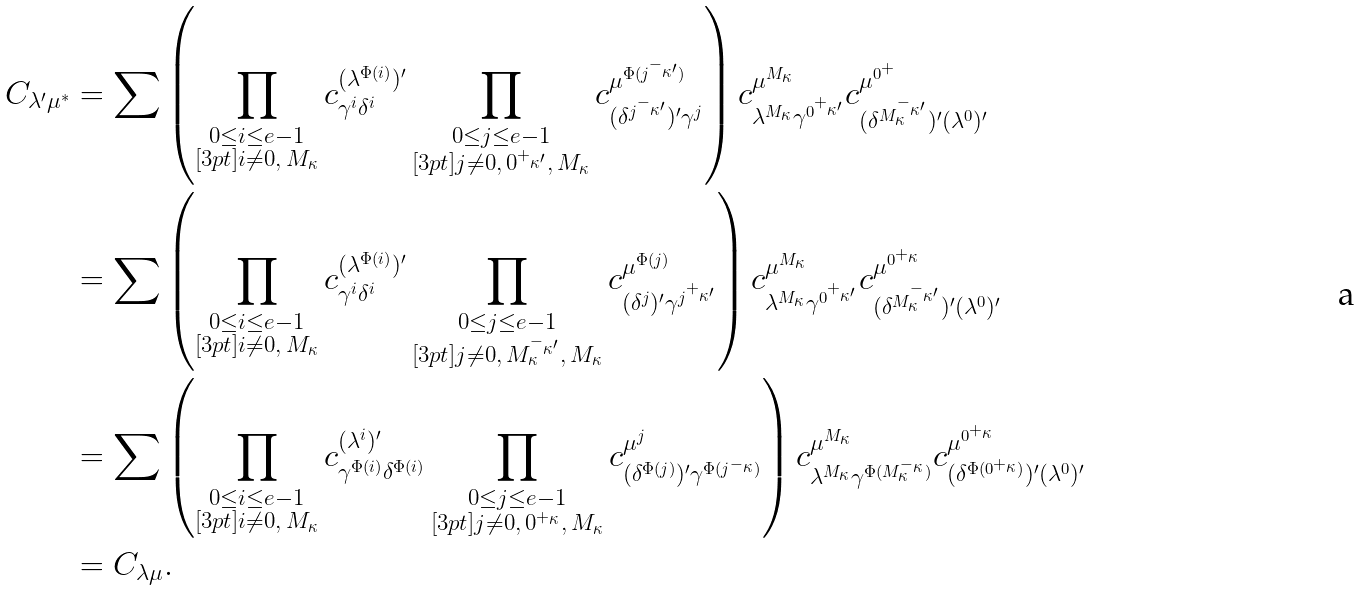<formula> <loc_0><loc_0><loc_500><loc_500>C _ { \lambda ^ { \prime } \mu ^ { * } } & = \sum \left ( \prod _ { \substack { 0 \leq i \leq e - 1 \\ [ 3 p t ] i \ne 0 , \, M _ { \kappa } } } c ^ { ( \lambda ^ { \Phi ( i ) } ) ^ { \prime } } _ { \gamma ^ { i } \delta ^ { i } } \prod _ { \substack { 0 \leq j \leq e - 1 \\ [ 3 p t ] j \ne 0 , \, 0 ^ { + _ { \kappa ^ { \prime } } } , \, M _ { \kappa } } } c ^ { \mu ^ { \Phi ( j ^ { - _ { \kappa ^ { \prime } } } ) } } _ { ( \delta ^ { j ^ { - _ { \kappa ^ { \prime } } } } ) ^ { \prime } \gamma ^ { j } } \right ) c ^ { \mu ^ { M _ { \kappa } } } _ { \lambda ^ { M _ { \kappa } } \gamma ^ { 0 ^ { + _ { \kappa ^ { \prime } } } } } c ^ { \mu ^ { 0 ^ { + } } } _ { ( \delta ^ { M _ { \kappa } ^ { - _ { \kappa ^ { \prime } } } } ) ^ { \prime } ( \lambda ^ { 0 } ) ^ { \prime } } \\ & = \sum \left ( \prod _ { \substack { 0 \leq i \leq e - 1 \\ [ 3 p t ] i \ne 0 , \, M _ { \kappa } } } c ^ { ( \lambda ^ { \Phi ( i ) } ) ^ { \prime } } _ { \gamma ^ { i } \delta ^ { i } } \prod _ { \substack { 0 \leq j \leq e - 1 \\ [ 3 p t ] j \ne 0 , \, M _ { \kappa } ^ { - _ { \kappa ^ { \prime } } } , \, M _ { \kappa } } } c ^ { \mu ^ { \Phi ( j ) } } _ { ( \delta ^ { j } ) ^ { \prime } \gamma ^ { j ^ { + _ { \kappa ^ { \prime } } } } } \right ) c ^ { \mu ^ { M _ { \kappa } } } _ { \lambda ^ { M _ { \kappa } } \gamma ^ { 0 ^ { + _ { \kappa ^ { \prime } } } } } c ^ { \mu ^ { 0 ^ { + _ { \kappa } } } } _ { ( \delta ^ { M _ { \kappa } ^ { - _ { \kappa ^ { \prime } } } } ) ^ { \prime } ( \lambda ^ { 0 } ) ^ { \prime } } \\ & = \sum \left ( \prod _ { \substack { 0 \leq i \leq e - 1 \\ [ 3 p t ] i \ne 0 , \, M _ { \kappa } } } c ^ { ( \lambda ^ { i } ) ^ { \prime } } _ { \gamma ^ { \Phi ( i ) } \delta ^ { \Phi ( i ) } } \prod _ { \substack { 0 \leq j \leq e - 1 \\ [ 3 p t ] j \ne 0 , \, 0 ^ { + _ { \kappa } } , \, M _ { \kappa } } } c ^ { \mu ^ { j } } _ { ( \delta ^ { \Phi ( j ) } ) ^ { \prime } \gamma ^ { \Phi ( j ^ { - _ { \kappa } } ) } } \right ) c ^ { \mu ^ { M _ { \kappa } } } _ { \lambda ^ { M _ { \kappa } } \gamma ^ { \Phi ( M _ { \kappa } ^ { - _ { \kappa } } ) } } c ^ { \mu ^ { 0 ^ { + _ { \kappa } } } } _ { ( \delta ^ { \Phi ( 0 ^ { + _ { \kappa } } ) } ) ^ { \prime } ( \lambda ^ { 0 } ) ^ { \prime } } \\ & = C _ { \lambda \mu } .</formula> 